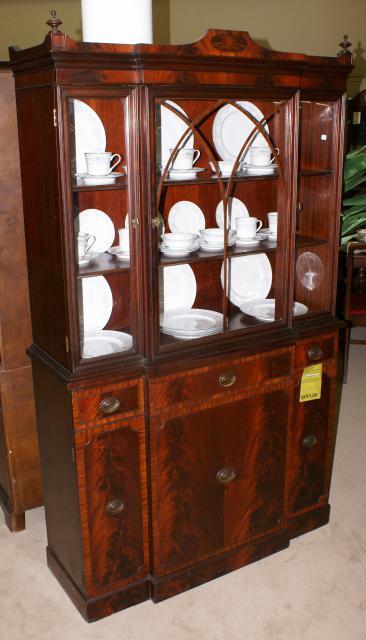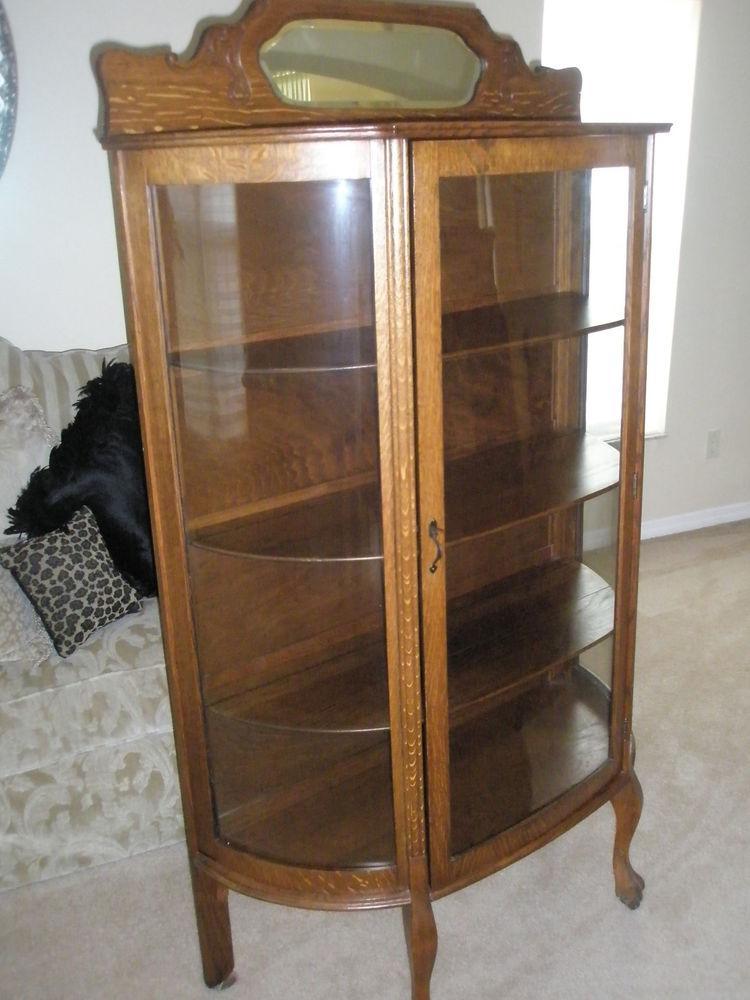The first image is the image on the left, the second image is the image on the right. Considering the images on both sides, is "All the cabinets have legs." valid? Answer yes or no. No. 